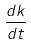<formula> <loc_0><loc_0><loc_500><loc_500>\frac { d k } { d t }</formula> 